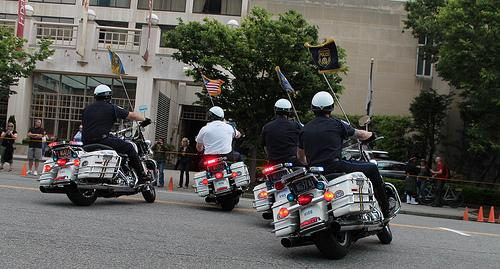Count and describe the types of headwear worn by the policemen. There are four white helmets, each with black elements, worn by the policemen. How many cones are present, and what color are they? There are three orange traffic cones. Explain the position and significance of the orange traffic cones. The orange traffic cones are placed on the side of the street, likely for safety reasons or to demarcate a specific route. What are the dominant colors present on officers' uniforms and motorcycles? The dominant colors are white, black, red, and green. Examine the street and mention any distinctive features seen on the pavement. The pavement is gray with white and orange painted lines, and there is a yellow line running across the road. Summarize the scene in the image involving four police officers and their motorcycles. Four police officers on large white motorcycles are making a turn on the road, wearing white helmets and black uniforms, with multiple flags accompanying them. Identify and describe the buildings in the image. There is a concrete building with a brown railing, a window on the side, and a red sign. Another tan building has a part of a window on the front and a small tree in front of it. Analyze the emotion or sentiment conveyed by the image. The image conveys a sense of order, authority, and safety, with the presence of police officers on motorcycles and orange traffic cones for guidance. Provide an overview of the people and objects present in the background. In the background, there are spectators watching a parade, parked vehicles beside a building, and a large green bush in front of a tan building. 